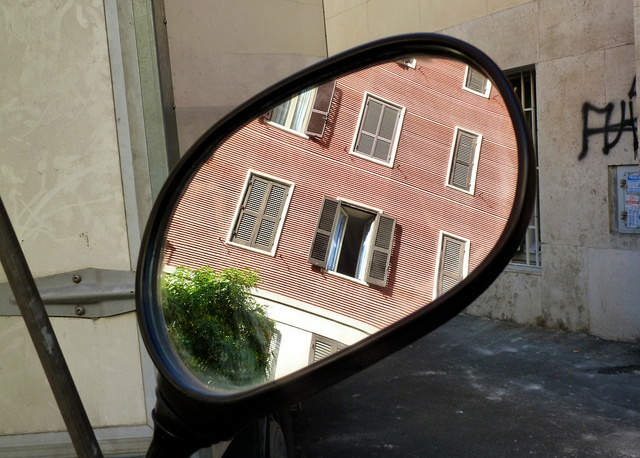Describe the objects in this image and their specific colors. I can see various objects in this image with different colors. 